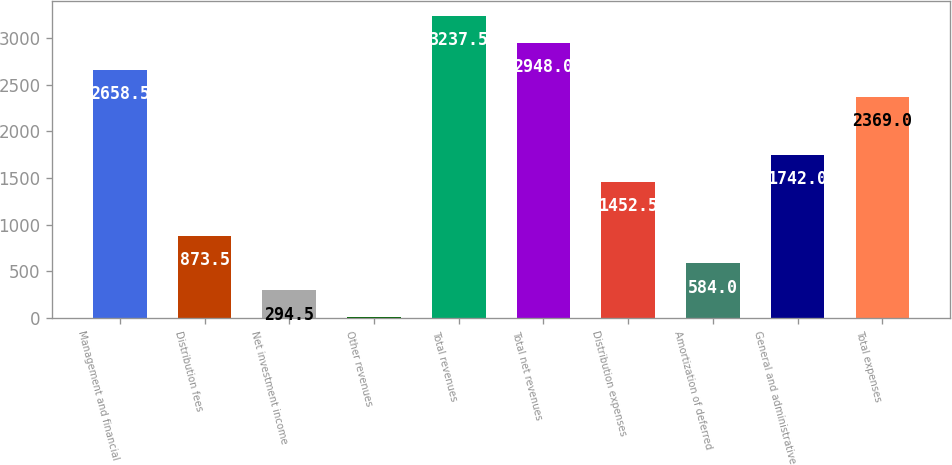Convert chart to OTSL. <chart><loc_0><loc_0><loc_500><loc_500><bar_chart><fcel>Management and financial<fcel>Distribution fees<fcel>Net investment income<fcel>Other revenues<fcel>Total revenues<fcel>Total net revenues<fcel>Distribution expenses<fcel>Amortization of deferred<fcel>General and administrative<fcel>Total expenses<nl><fcel>2658.5<fcel>873.5<fcel>294.5<fcel>5<fcel>3237.5<fcel>2948<fcel>1452.5<fcel>584<fcel>1742<fcel>2369<nl></chart> 